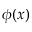Convert formula to latex. <formula><loc_0><loc_0><loc_500><loc_500>\phi ( x )</formula> 